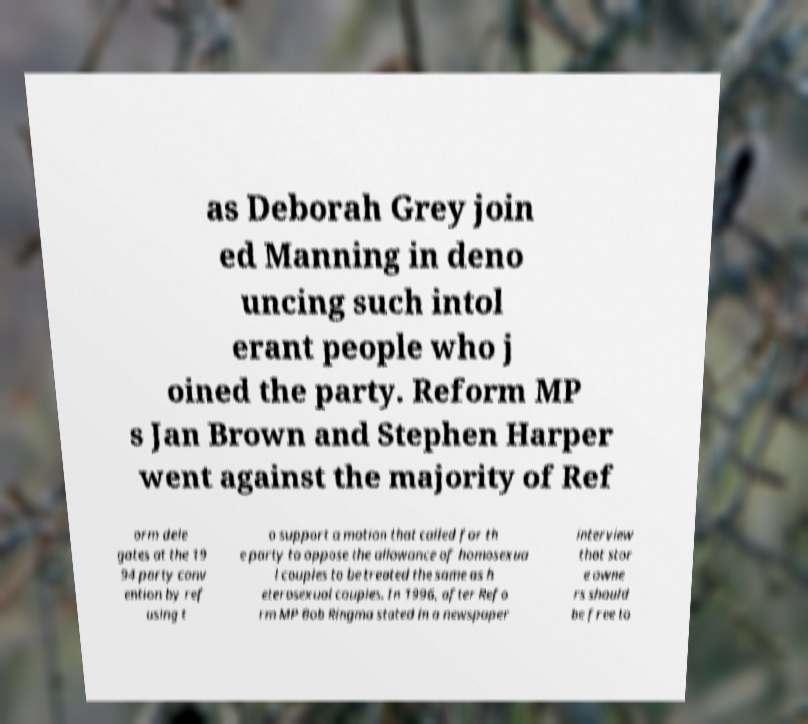There's text embedded in this image that I need extracted. Can you transcribe it verbatim? as Deborah Grey join ed Manning in deno uncing such intol erant people who j oined the party. Reform MP s Jan Brown and Stephen Harper went against the majority of Ref orm dele gates at the 19 94 party conv ention by ref using t o support a motion that called for th e party to oppose the allowance of homosexua l couples to be treated the same as h eterosexual couples. In 1996, after Refo rm MP Bob Ringma stated in a newspaper interview that stor e owne rs should be free to 